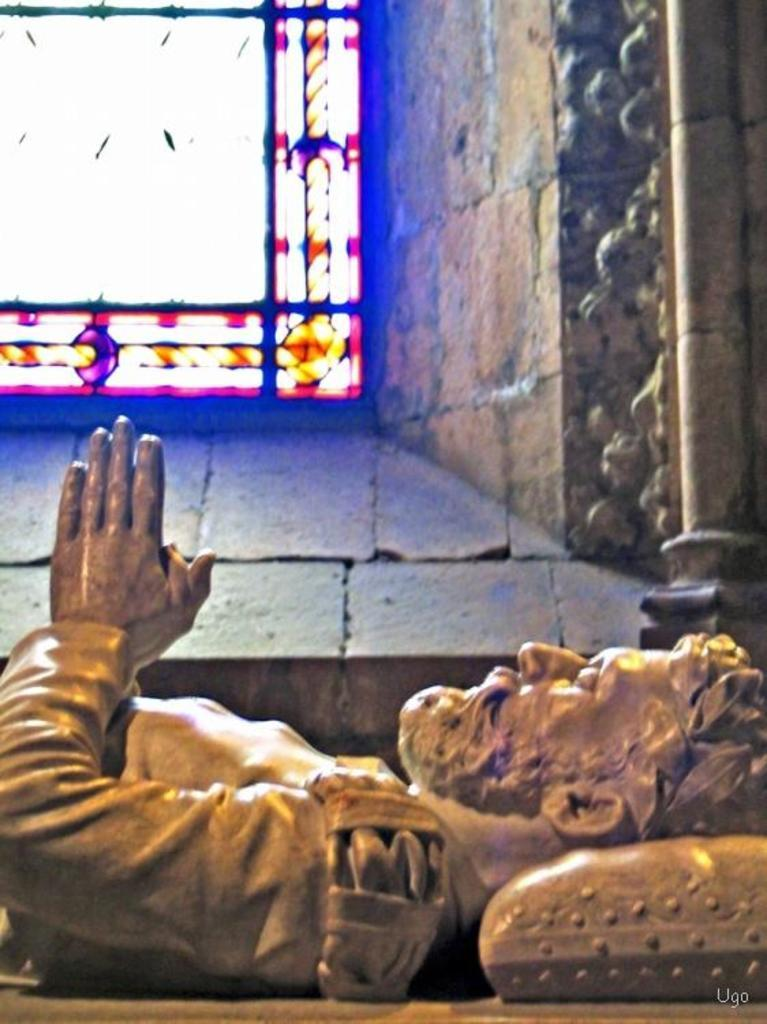What is the main subject of the image? There is a sculpture of a person in the image. How is the sculpture positioned in the image? The sculpture is laying on a surface. What can be seen in the background of the image? There is a wall and glass in the background of the image. What organization is the sculpture representing in the image? There is no indication in the image that the sculpture represents any organization. Can you tell me how many times the person in the sculpture jumps in the image? The sculpture is laying on a surface, so there is no jumping motion depicted in the image. 